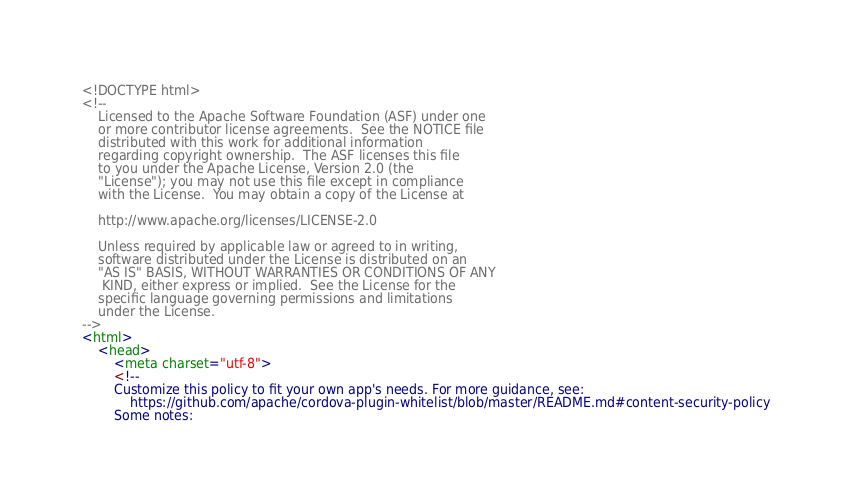<code> <loc_0><loc_0><loc_500><loc_500><_HTML_><!DOCTYPE html>
<!--
    Licensed to the Apache Software Foundation (ASF) under one
    or more contributor license agreements.  See the NOTICE file
    distributed with this work for additional information
    regarding copyright ownership.  The ASF licenses this file
    to you under the Apache License, Version 2.0 (the
    "License"); you may not use this file except in compliance
    with the License.  You may obtain a copy of the License at

    http://www.apache.org/licenses/LICENSE-2.0

    Unless required by applicable law or agreed to in writing,
    software distributed under the License is distributed on an
    "AS IS" BASIS, WITHOUT WARRANTIES OR CONDITIONS OF ANY
     KIND, either express or implied.  See the License for the
    specific language governing permissions and limitations
    under the License.
-->
<html>
    <head>
        <meta charset="utf-8">
        <!--
        Customize this policy to fit your own app's needs. For more guidance, see:
            https://github.com/apache/cordova-plugin-whitelist/blob/master/README.md#content-security-policy
        Some notes:</code> 